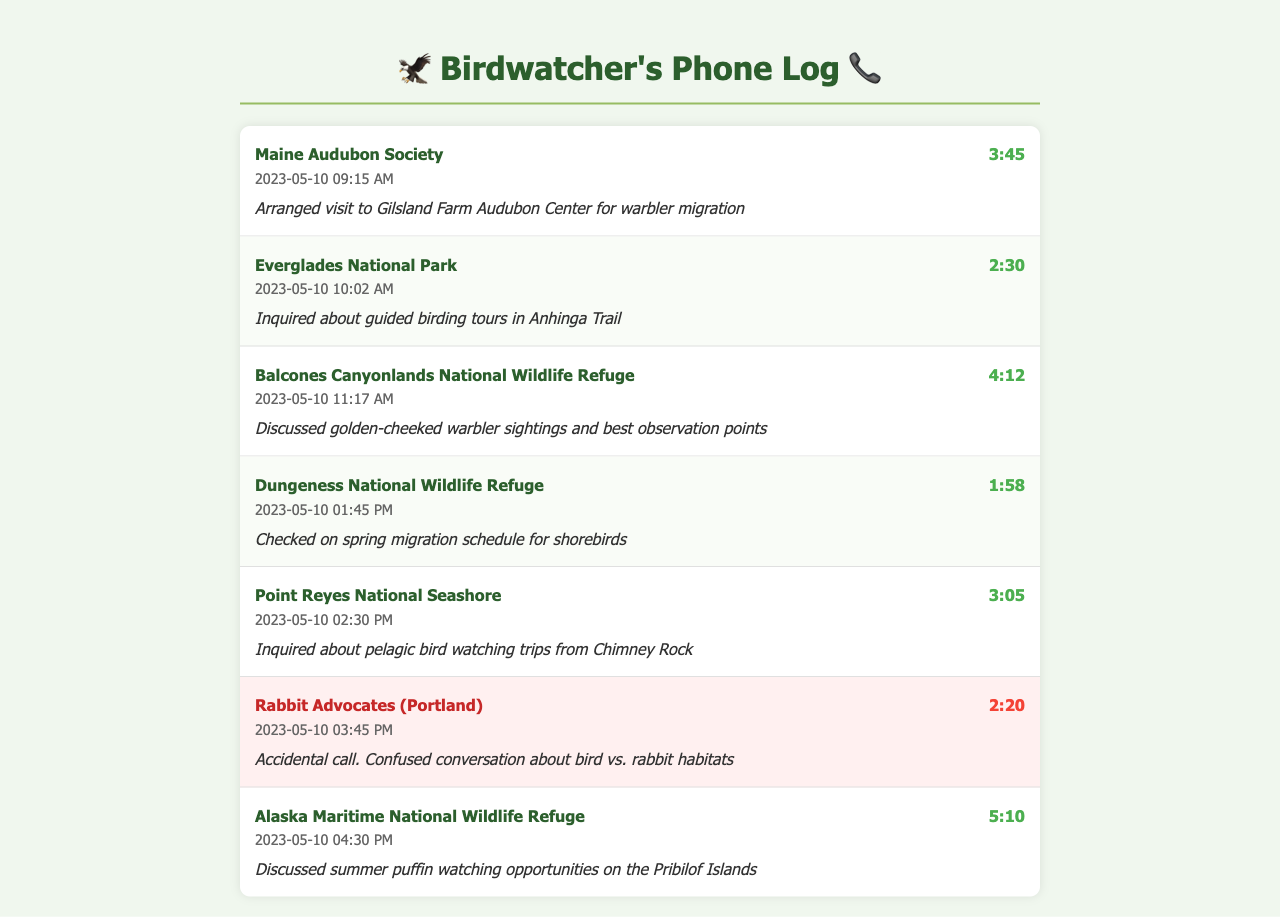What is the name of the last sanctuary contacted? The last sanctuary contacted in the log is Alaska Maritime National Wildlife Refuge.
Answer: Alaska Maritime National Wildlife Refuge How long was the call to the Rabbit Advocates (Portland)? The duration of the call to Rabbit Advocates (Portland) is noted in the log as 2:20.
Answer: 2:20 Which sanctuary arranged a visit for the warbler migration? The call that arranged a visit for the warbler migration was to Maine Audubon Society.
Answer: Maine Audubon Society What time was the call to Point Reyes National Seashore made? The call to Point Reyes National Seashore was made at 02:30 PM.
Answer: 02:30 PM What was discussed during the call to Dungeness National Wildlife Refuge? The discussion during the call to Dungeness National Wildlife Refuge was about the spring migration schedule for shorebirds.
Answer: Spring migration schedule for shorebirds How many total unique sanctuaries were contacted? The number of unique sanctuaries contacted in the log is six, excluding the Rabbit Advocates.
Answer: Six What type of inquiry was made to Everglades National Park? An inquiry about guided birding tours was made to Everglades National Park.
Answer: Guided birding tours What was the purpose of the call to Rabbit Advocates (Portland)? The purpose of the call to Rabbit Advocates (Portland) was an accidental call with a confused conversation about bird vs. rabbit habitats.
Answer: Accidental call What event did the call to Balcones Canyonlands discuss? The call to Balcones Canyonlands National Wildlife Refuge discussed golden-cheeked warbler sightings.
Answer: Golden-cheeked warbler sightings 